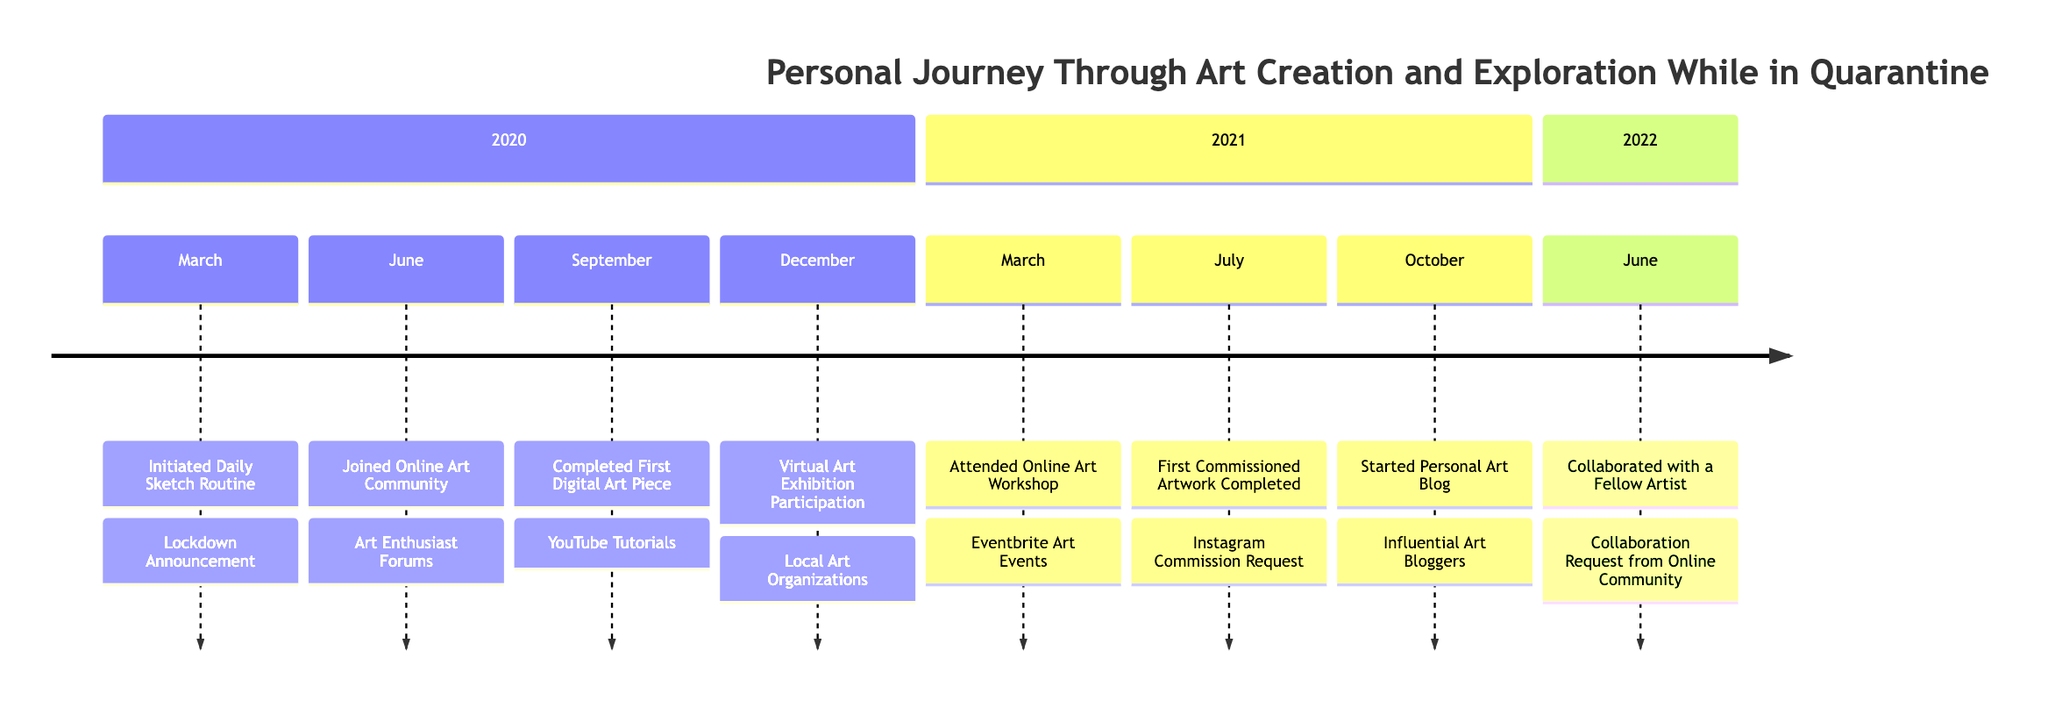What milestone occurred in March 2020? The diagram clearly indicates that in March 2020, the milestone was "Initiated Daily Sketch Routine." This information is located in the first section of the timeline.
Answer: Initiated Daily Sketch Routine How many milestones are shown in the year 2021? By counting the milestones listed in the 2021 section of the timeline, we can see three accomplishments: "Attended Online Art Workshop," "First Commissioned Artwork Completed," and "Started Personal Art Blog." Thus, the total is three milestones.
Answer: 3 What was the influence for the "First Commissioned Artwork Completed"? The timeline specifies that the influence for "First Commissioned Artwork Completed" was "Instagram Commission Request," which is directly listed beside the milestone in the July 2021 section.
Answer: Instagram Commission Request Which milestone was influenced by YouTube tutorials? The timeline indicates that "Completed First Digital Art Piece" was influenced by YouTube tutorials. This connection is drawn from the September 2020 milestone.
Answer: Completed First Digital Art Piece What month and year did the "Collaborated with a Fellow Artist" milestone occur? Looking at the timeline, it shows that the milestone "Collaborated with a Fellow Artist" took place in June 2022, as indicated in the final section on the diagram.
Answer: June 2022 Which milestone comes directly after the "Joined Online Art Community"? In the timeline's flow, after "Joined Online Art Community" in June 2020, the next milestone listed is "Completed First Digital Art Piece" in September 2020, indicating a progression from one milestone to the next.
Answer: Completed First Digital Art Piece What was the main influence for the "Virtual Art Exhibition Participation"? According to the diagram, the influence for "Virtual Art Exhibition Participation" in December 2020 was from "Local Art Organizations," which is noted next to the milestone.
Answer: Local Art Organizations How many total milestones are represented in the timeline? By counting all the listed milestones across the three sections (2020, 2021, 2022), there are a total of eight milestones present in the timeline.
Answer: 8 